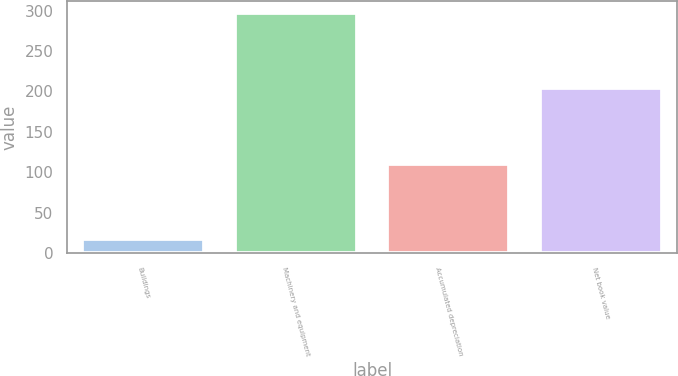Convert chart to OTSL. <chart><loc_0><loc_0><loc_500><loc_500><bar_chart><fcel>Buildings<fcel>Machinery and equipment<fcel>Accumulated depreciation<fcel>Net book value<nl><fcel>17<fcel>297<fcel>110<fcel>204<nl></chart> 